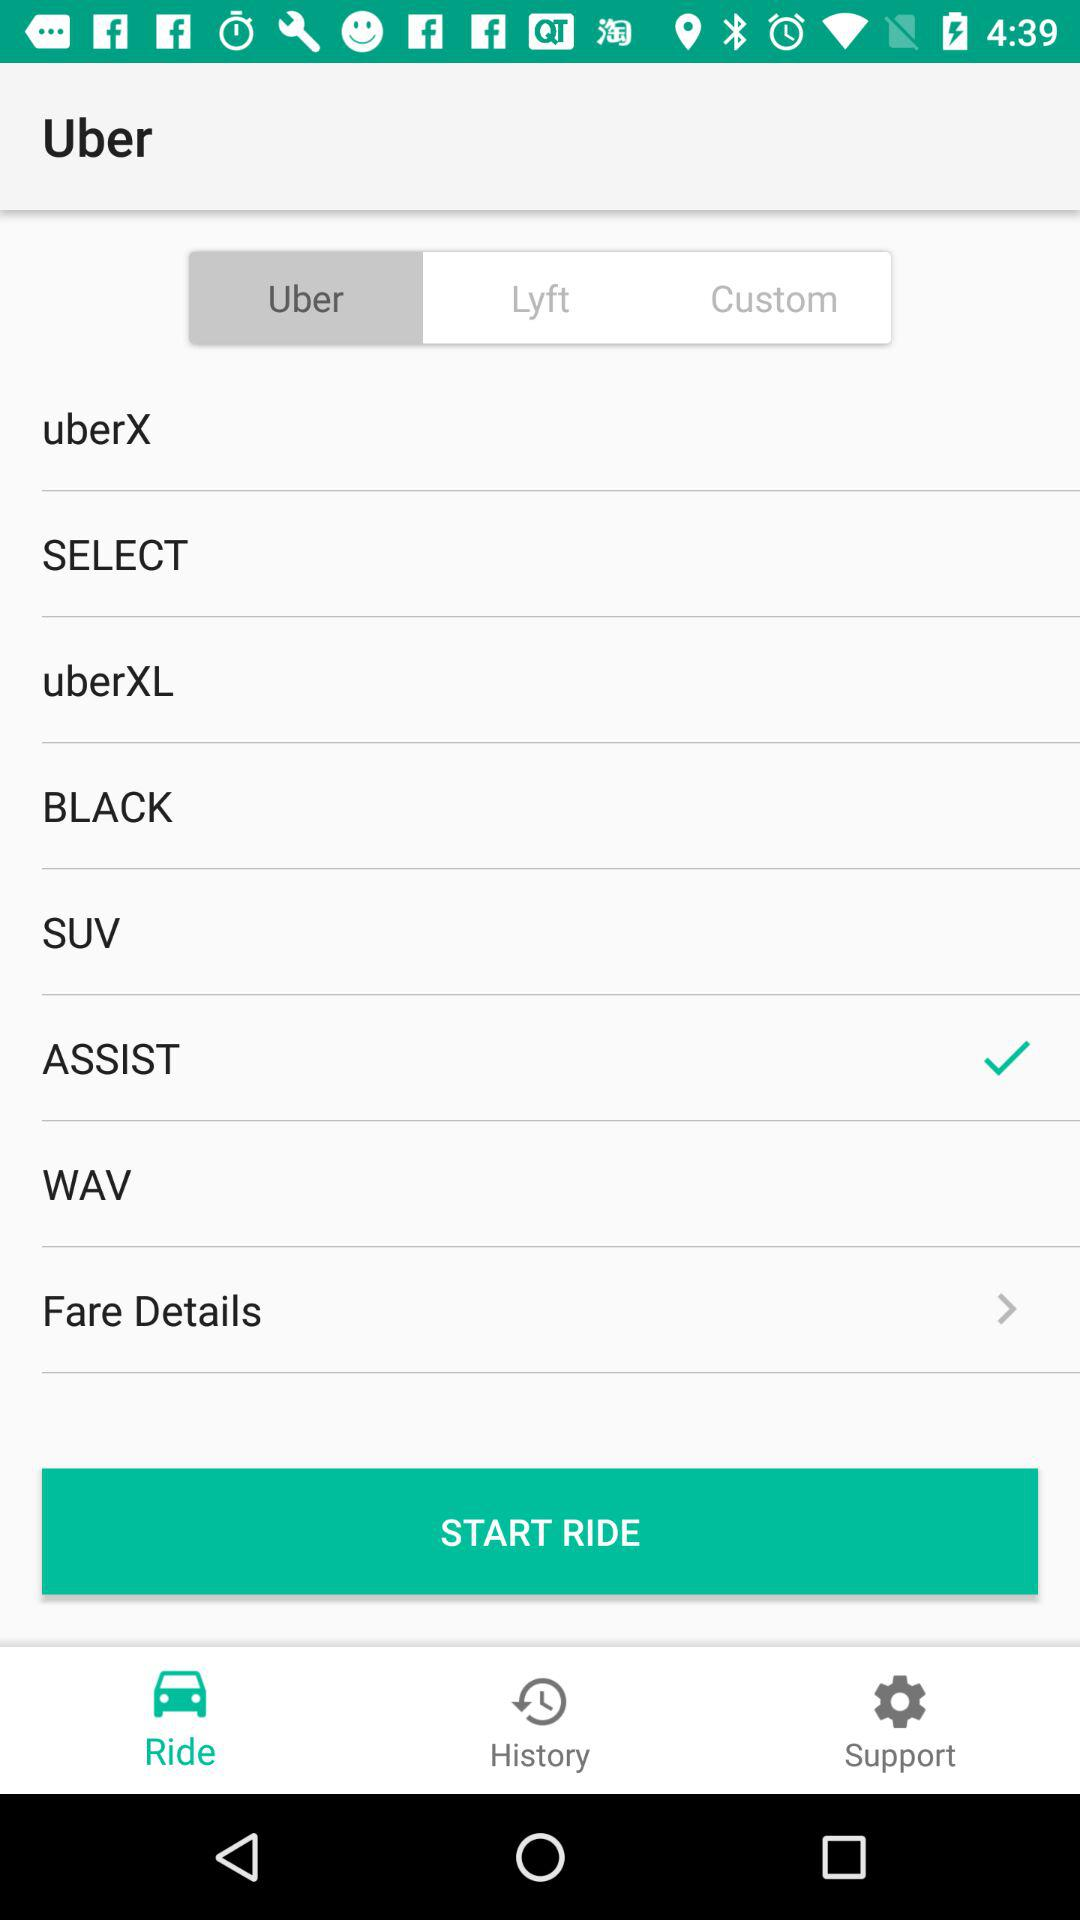Which option is selected? The selected options are "Uber", "ASSIST" and "Ride". 